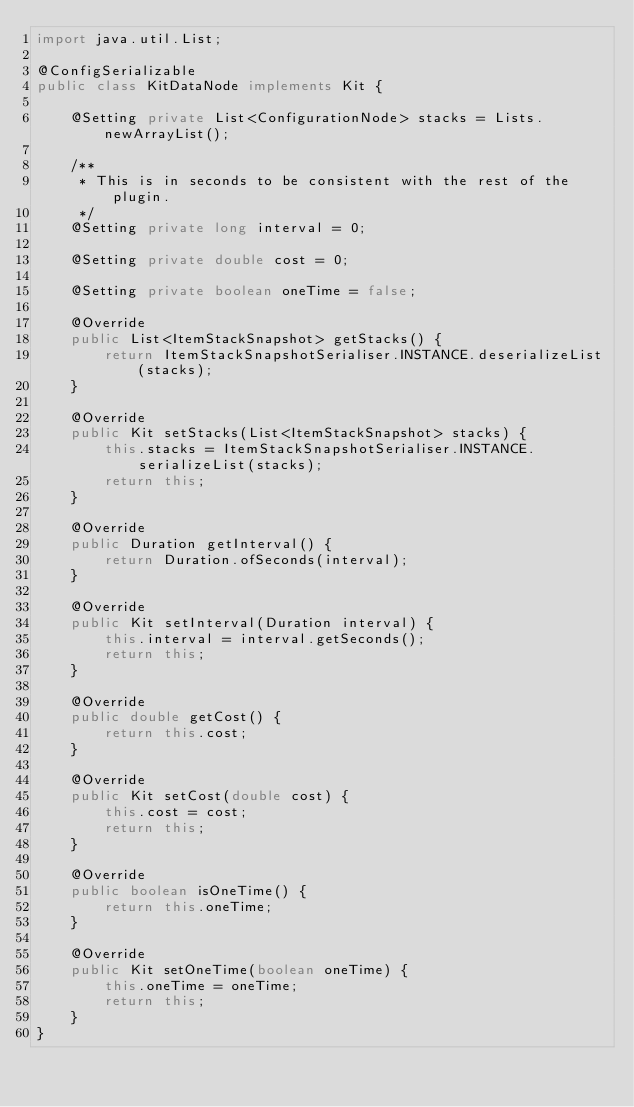<code> <loc_0><loc_0><loc_500><loc_500><_Java_>import java.util.List;

@ConfigSerializable
public class KitDataNode implements Kit {

    @Setting private List<ConfigurationNode> stacks = Lists.newArrayList();

    /**
     * This is in seconds to be consistent with the rest of the plugin.
     */
    @Setting private long interval = 0;

    @Setting private double cost = 0;

    @Setting private boolean oneTime = false;

    @Override
    public List<ItemStackSnapshot> getStacks() {
        return ItemStackSnapshotSerialiser.INSTANCE.deserializeList(stacks);
    }

    @Override
    public Kit setStacks(List<ItemStackSnapshot> stacks) {
        this.stacks = ItemStackSnapshotSerialiser.INSTANCE.serializeList(stacks);
        return this;
    }

    @Override
    public Duration getInterval() {
        return Duration.ofSeconds(interval);
    }

    @Override
    public Kit setInterval(Duration interval) {
        this.interval = interval.getSeconds();
        return this;
    }

    @Override
    public double getCost() {
        return this.cost;
    }

    @Override
    public Kit setCost(double cost) {
        this.cost = cost;
        return this;
    }

    @Override
    public boolean isOneTime() {
        return this.oneTime;
    }

    @Override
    public Kit setOneTime(boolean oneTime) {
        this.oneTime = oneTime;
        return this;
    }
}
</code> 